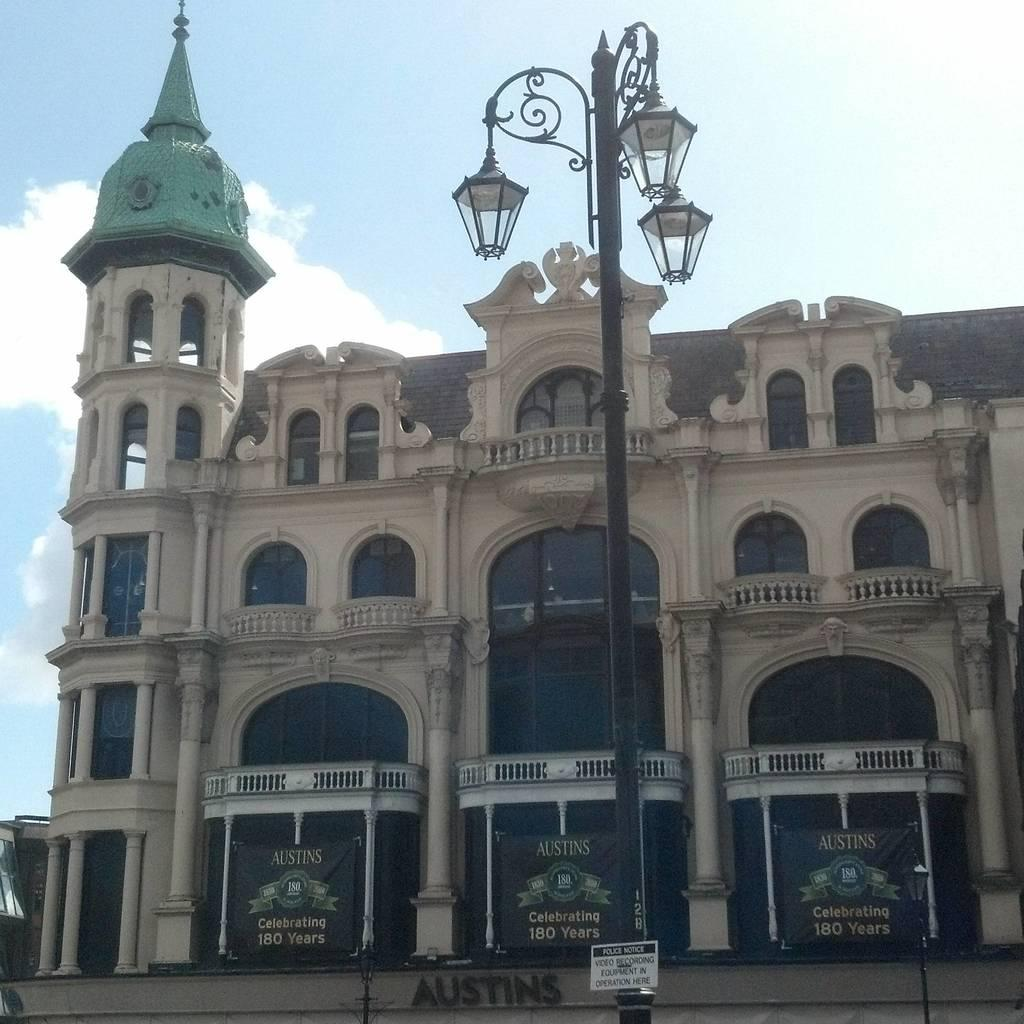<image>
Present a compact description of the photo's key features. An old stone building with the word "Austins" on the front. 